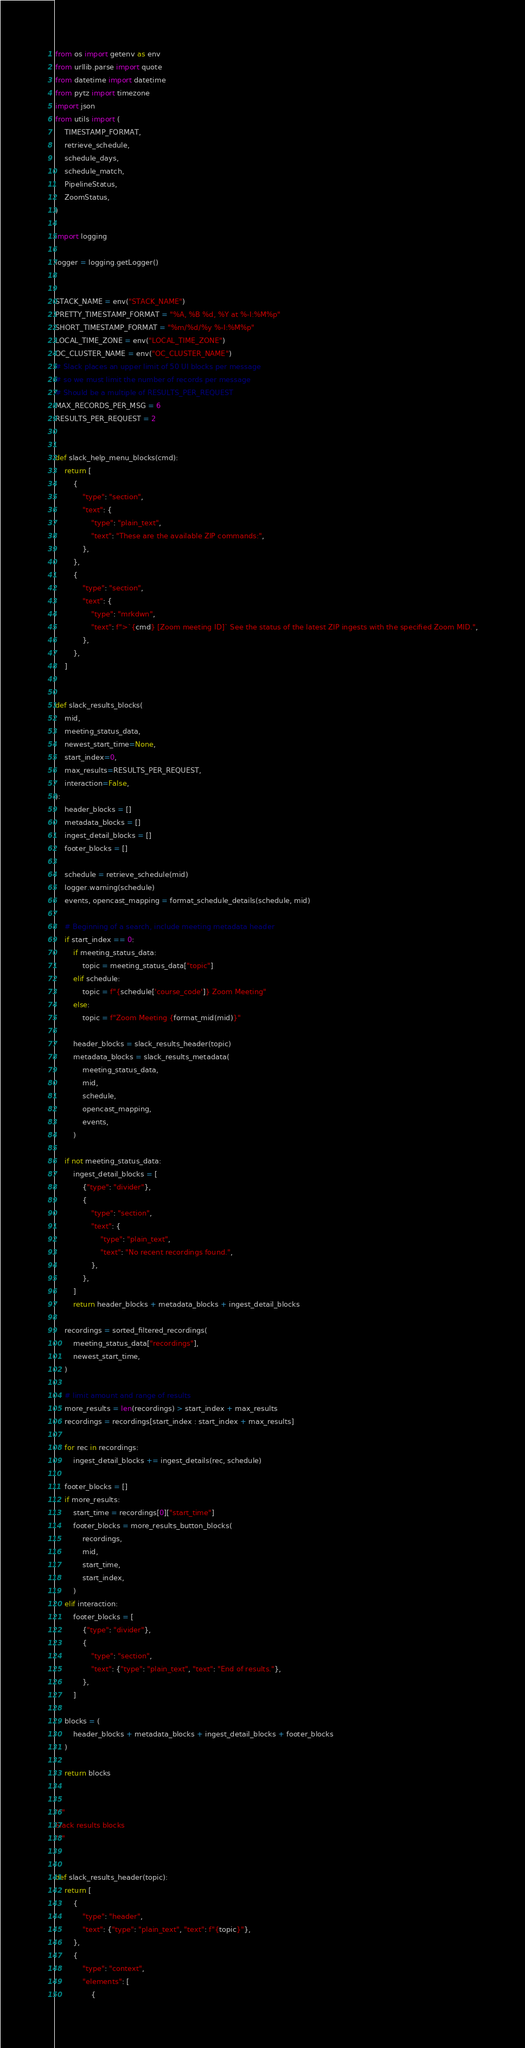<code> <loc_0><loc_0><loc_500><loc_500><_Python_>from os import getenv as env
from urllib.parse import quote
from datetime import datetime
from pytz import timezone
import json
from utils import (
    TIMESTAMP_FORMAT,
    retrieve_schedule,
    schedule_days,
    schedule_match,
    PipelineStatus,
    ZoomStatus,
)

import logging

logger = logging.getLogger()


STACK_NAME = env("STACK_NAME")
PRETTY_TIMESTAMP_FORMAT = "%A, %B %d, %Y at %-I:%M%p"
SHORT_TIMESTAMP_FORMAT = "%m/%d/%y %-I:%M%p"
LOCAL_TIME_ZONE = env("LOCAL_TIME_ZONE")
OC_CLUSTER_NAME = env("OC_CLUSTER_NAME")
# Slack places an upper limit of 50 UI blocks per message
# so we must limit the number of records per message
# Should be a multiple of RESULTS_PER_REQUEST
MAX_RECORDS_PER_MSG = 6
RESULTS_PER_REQUEST = 2


def slack_help_menu_blocks(cmd):
    return [
        {
            "type": "section",
            "text": {
                "type": "plain_text",
                "text": "These are the available ZIP commands:",
            },
        },
        {
            "type": "section",
            "text": {
                "type": "mrkdwn",
                "text": f">`{cmd} [Zoom meeting ID]` See the status of the latest ZIP ingests with the specified Zoom MID.",
            },
        },
    ]


def slack_results_blocks(
    mid,
    meeting_status_data,
    newest_start_time=None,
    start_index=0,
    max_results=RESULTS_PER_REQUEST,
    interaction=False,
):
    header_blocks = []
    metadata_blocks = []
    ingest_detail_blocks = []
    footer_blocks = []

    schedule = retrieve_schedule(mid)
    logger.warning(schedule)
    events, opencast_mapping = format_schedule_details(schedule, mid)

    # Beginning of a search, include meeting metadata header
    if start_index == 0:
        if meeting_status_data:
            topic = meeting_status_data["topic"]
        elif schedule:
            topic = f"{schedule['course_code']} Zoom Meeting"
        else:
            topic = f"Zoom Meeting {format_mid(mid)}"

        header_blocks = slack_results_header(topic)
        metadata_blocks = slack_results_metadata(
            meeting_status_data,
            mid,
            schedule,
            opencast_mapping,
            events,
        )

    if not meeting_status_data:
        ingest_detail_blocks = [
            {"type": "divider"},
            {
                "type": "section",
                "text": {
                    "type": "plain_text",
                    "text": "No recent recordings found.",
                },
            },
        ]
        return header_blocks + metadata_blocks + ingest_detail_blocks

    recordings = sorted_filtered_recordings(
        meeting_status_data["recordings"],
        newest_start_time,
    )

    # limit amount and range of results
    more_results = len(recordings) > start_index + max_results
    recordings = recordings[start_index : start_index + max_results]

    for rec in recordings:
        ingest_detail_blocks += ingest_details(rec, schedule)

    footer_blocks = []
    if more_results:
        start_time = recordings[0]["start_time"]
        footer_blocks = more_results_button_blocks(
            recordings,
            mid,
            start_time,
            start_index,
        )
    elif interaction:
        footer_blocks = [
            {"type": "divider"},
            {
                "type": "section",
                "text": {"type": "plain_text", "text": "End of results."},
            },
        ]

    blocks = (
        header_blocks + metadata_blocks + ingest_detail_blocks + footer_blocks
    )

    return blocks


"""
Slack results blocks
"""


def slack_results_header(topic):
    return [
        {
            "type": "header",
            "text": {"type": "plain_text", "text": f"{topic}"},
        },
        {
            "type": "context",
            "elements": [
                {</code> 